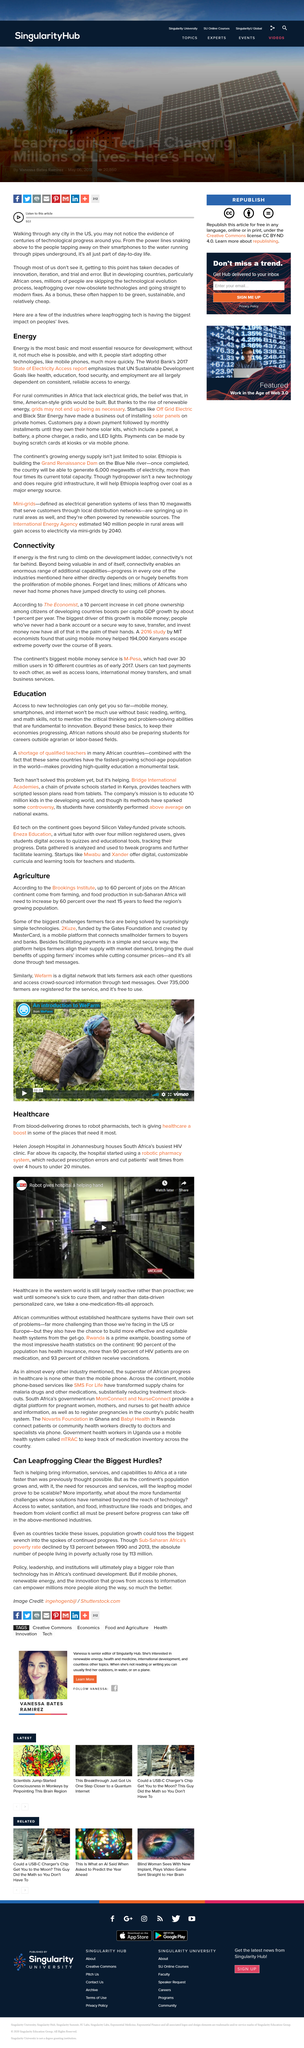Identify some key points in this picture. A 10% increase in cell phone ownership among citizens of developing countries, as reported by The Economist, resulted in an annual increase in per capita GDP growth of approximately 1% per year, according to their findings. The United Nations Sustainable Development Goals are: health, education, food security, and employment. Mobile money is the biggest driver of growth connected to connectivity in Africa, as it provides individuals with a secure and convenient means of saving, transferring, and investing their money, which they previously lacked due to limited access to traditional banking services. There is a significant shortage of qualified teachers in many African countries. The implementation of a robotic pharmacy system resulted in a significant reduction in patient wait time, from an average of 4 hours to just 20 minutes. 